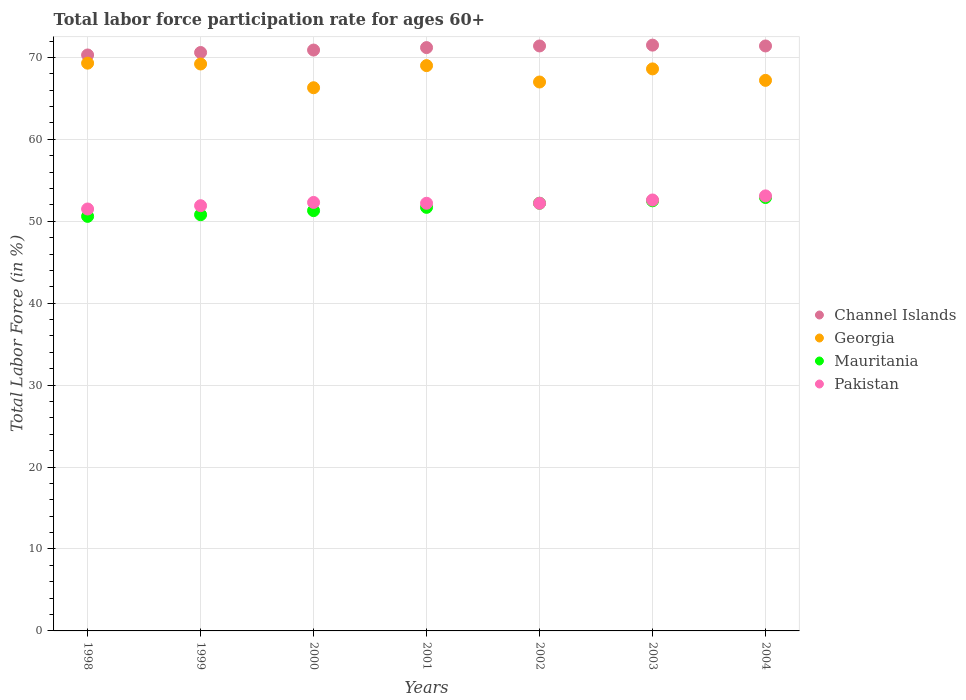What is the labor force participation rate in Pakistan in 2004?
Your response must be concise. 53.1. Across all years, what is the maximum labor force participation rate in Channel Islands?
Provide a succinct answer. 71.5. Across all years, what is the minimum labor force participation rate in Mauritania?
Your response must be concise. 50.6. In which year was the labor force participation rate in Channel Islands minimum?
Give a very brief answer. 1998. What is the total labor force participation rate in Georgia in the graph?
Offer a terse response. 476.6. What is the difference between the labor force participation rate in Georgia in 2002 and the labor force participation rate in Channel Islands in 2000?
Make the answer very short. -3.9. What is the average labor force participation rate in Channel Islands per year?
Provide a short and direct response. 71.04. In the year 1998, what is the difference between the labor force participation rate in Georgia and labor force participation rate in Pakistan?
Your answer should be very brief. 17.8. In how many years, is the labor force participation rate in Pakistan greater than 70 %?
Make the answer very short. 0. What is the ratio of the labor force participation rate in Georgia in 1998 to that in 2003?
Your answer should be very brief. 1.01. Is the difference between the labor force participation rate in Georgia in 1998 and 2001 greater than the difference between the labor force participation rate in Pakistan in 1998 and 2001?
Offer a terse response. Yes. What is the difference between the highest and the second highest labor force participation rate in Channel Islands?
Provide a short and direct response. 0.1. What is the difference between the highest and the lowest labor force participation rate in Mauritania?
Offer a terse response. 2.3. In how many years, is the labor force participation rate in Georgia greater than the average labor force participation rate in Georgia taken over all years?
Offer a terse response. 4. Is it the case that in every year, the sum of the labor force participation rate in Georgia and labor force participation rate in Pakistan  is greater than the sum of labor force participation rate in Mauritania and labor force participation rate in Channel Islands?
Your answer should be very brief. Yes. Is it the case that in every year, the sum of the labor force participation rate in Mauritania and labor force participation rate in Channel Islands  is greater than the labor force participation rate in Georgia?
Your answer should be compact. Yes. Does the labor force participation rate in Channel Islands monotonically increase over the years?
Your answer should be compact. No. How many dotlines are there?
Offer a terse response. 4. How many years are there in the graph?
Keep it short and to the point. 7. Are the values on the major ticks of Y-axis written in scientific E-notation?
Your response must be concise. No. Does the graph contain grids?
Ensure brevity in your answer.  Yes. Where does the legend appear in the graph?
Provide a short and direct response. Center right. How many legend labels are there?
Keep it short and to the point. 4. What is the title of the graph?
Your answer should be compact. Total labor force participation rate for ages 60+. Does "Cote d'Ivoire" appear as one of the legend labels in the graph?
Your answer should be compact. No. What is the label or title of the Y-axis?
Give a very brief answer. Total Labor Force (in %). What is the Total Labor Force (in %) of Channel Islands in 1998?
Offer a very short reply. 70.3. What is the Total Labor Force (in %) of Georgia in 1998?
Keep it short and to the point. 69.3. What is the Total Labor Force (in %) of Mauritania in 1998?
Make the answer very short. 50.6. What is the Total Labor Force (in %) in Pakistan in 1998?
Make the answer very short. 51.5. What is the Total Labor Force (in %) of Channel Islands in 1999?
Keep it short and to the point. 70.6. What is the Total Labor Force (in %) of Georgia in 1999?
Give a very brief answer. 69.2. What is the Total Labor Force (in %) in Mauritania in 1999?
Provide a short and direct response. 50.8. What is the Total Labor Force (in %) in Pakistan in 1999?
Keep it short and to the point. 51.9. What is the Total Labor Force (in %) of Channel Islands in 2000?
Provide a succinct answer. 70.9. What is the Total Labor Force (in %) of Georgia in 2000?
Offer a terse response. 66.3. What is the Total Labor Force (in %) of Mauritania in 2000?
Provide a succinct answer. 51.3. What is the Total Labor Force (in %) of Pakistan in 2000?
Keep it short and to the point. 52.3. What is the Total Labor Force (in %) of Channel Islands in 2001?
Make the answer very short. 71.2. What is the Total Labor Force (in %) of Georgia in 2001?
Offer a terse response. 69. What is the Total Labor Force (in %) of Mauritania in 2001?
Your answer should be compact. 51.7. What is the Total Labor Force (in %) of Pakistan in 2001?
Keep it short and to the point. 52.2. What is the Total Labor Force (in %) in Channel Islands in 2002?
Your answer should be compact. 71.4. What is the Total Labor Force (in %) of Mauritania in 2002?
Keep it short and to the point. 52.2. What is the Total Labor Force (in %) of Pakistan in 2002?
Offer a terse response. 52.2. What is the Total Labor Force (in %) of Channel Islands in 2003?
Provide a succinct answer. 71.5. What is the Total Labor Force (in %) in Georgia in 2003?
Give a very brief answer. 68.6. What is the Total Labor Force (in %) of Mauritania in 2003?
Give a very brief answer. 52.5. What is the Total Labor Force (in %) in Pakistan in 2003?
Ensure brevity in your answer.  52.6. What is the Total Labor Force (in %) of Channel Islands in 2004?
Your answer should be very brief. 71.4. What is the Total Labor Force (in %) of Georgia in 2004?
Offer a terse response. 67.2. What is the Total Labor Force (in %) in Mauritania in 2004?
Provide a succinct answer. 52.9. What is the Total Labor Force (in %) of Pakistan in 2004?
Offer a very short reply. 53.1. Across all years, what is the maximum Total Labor Force (in %) in Channel Islands?
Your answer should be compact. 71.5. Across all years, what is the maximum Total Labor Force (in %) in Georgia?
Make the answer very short. 69.3. Across all years, what is the maximum Total Labor Force (in %) in Mauritania?
Your answer should be compact. 52.9. Across all years, what is the maximum Total Labor Force (in %) of Pakistan?
Keep it short and to the point. 53.1. Across all years, what is the minimum Total Labor Force (in %) of Channel Islands?
Give a very brief answer. 70.3. Across all years, what is the minimum Total Labor Force (in %) of Georgia?
Ensure brevity in your answer.  66.3. Across all years, what is the minimum Total Labor Force (in %) of Mauritania?
Offer a very short reply. 50.6. Across all years, what is the minimum Total Labor Force (in %) of Pakistan?
Make the answer very short. 51.5. What is the total Total Labor Force (in %) in Channel Islands in the graph?
Offer a very short reply. 497.3. What is the total Total Labor Force (in %) in Georgia in the graph?
Provide a short and direct response. 476.6. What is the total Total Labor Force (in %) of Mauritania in the graph?
Your answer should be compact. 362. What is the total Total Labor Force (in %) in Pakistan in the graph?
Offer a terse response. 365.8. What is the difference between the Total Labor Force (in %) of Mauritania in 1998 and that in 1999?
Provide a short and direct response. -0.2. What is the difference between the Total Labor Force (in %) in Mauritania in 1998 and that in 2000?
Offer a terse response. -0.7. What is the difference between the Total Labor Force (in %) in Georgia in 1998 and that in 2002?
Provide a short and direct response. 2.3. What is the difference between the Total Labor Force (in %) in Mauritania in 1998 and that in 2002?
Provide a short and direct response. -1.6. What is the difference between the Total Labor Force (in %) in Channel Islands in 1998 and that in 2003?
Ensure brevity in your answer.  -1.2. What is the difference between the Total Labor Force (in %) in Pakistan in 1998 and that in 2003?
Make the answer very short. -1.1. What is the difference between the Total Labor Force (in %) of Georgia in 1998 and that in 2004?
Your answer should be very brief. 2.1. What is the difference between the Total Labor Force (in %) in Mauritania in 1998 and that in 2004?
Keep it short and to the point. -2.3. What is the difference between the Total Labor Force (in %) in Pakistan in 1998 and that in 2004?
Your response must be concise. -1.6. What is the difference between the Total Labor Force (in %) in Channel Islands in 1999 and that in 2000?
Provide a short and direct response. -0.3. What is the difference between the Total Labor Force (in %) of Georgia in 1999 and that in 2000?
Ensure brevity in your answer.  2.9. What is the difference between the Total Labor Force (in %) in Mauritania in 1999 and that in 2000?
Make the answer very short. -0.5. What is the difference between the Total Labor Force (in %) of Georgia in 1999 and that in 2001?
Keep it short and to the point. 0.2. What is the difference between the Total Labor Force (in %) in Channel Islands in 1999 and that in 2002?
Make the answer very short. -0.8. What is the difference between the Total Labor Force (in %) of Mauritania in 1999 and that in 2003?
Your response must be concise. -1.7. What is the difference between the Total Labor Force (in %) in Pakistan in 1999 and that in 2003?
Your answer should be very brief. -0.7. What is the difference between the Total Labor Force (in %) of Channel Islands in 1999 and that in 2004?
Make the answer very short. -0.8. What is the difference between the Total Labor Force (in %) in Channel Islands in 2000 and that in 2001?
Offer a very short reply. -0.3. What is the difference between the Total Labor Force (in %) of Georgia in 2000 and that in 2001?
Provide a succinct answer. -2.7. What is the difference between the Total Labor Force (in %) in Pakistan in 2000 and that in 2001?
Make the answer very short. 0.1. What is the difference between the Total Labor Force (in %) in Channel Islands in 2000 and that in 2002?
Make the answer very short. -0.5. What is the difference between the Total Labor Force (in %) in Georgia in 2000 and that in 2002?
Offer a terse response. -0.7. What is the difference between the Total Labor Force (in %) in Pakistan in 2000 and that in 2002?
Keep it short and to the point. 0.1. What is the difference between the Total Labor Force (in %) of Mauritania in 2000 and that in 2003?
Ensure brevity in your answer.  -1.2. What is the difference between the Total Labor Force (in %) of Pakistan in 2000 and that in 2003?
Make the answer very short. -0.3. What is the difference between the Total Labor Force (in %) of Georgia in 2001 and that in 2002?
Provide a short and direct response. 2. What is the difference between the Total Labor Force (in %) of Mauritania in 2001 and that in 2003?
Provide a short and direct response. -0.8. What is the difference between the Total Labor Force (in %) in Pakistan in 2001 and that in 2003?
Your answer should be compact. -0.4. What is the difference between the Total Labor Force (in %) in Channel Islands in 2001 and that in 2004?
Your answer should be very brief. -0.2. What is the difference between the Total Labor Force (in %) in Georgia in 2001 and that in 2004?
Provide a short and direct response. 1.8. What is the difference between the Total Labor Force (in %) in Mauritania in 2001 and that in 2004?
Your answer should be very brief. -1.2. What is the difference between the Total Labor Force (in %) of Pakistan in 2001 and that in 2004?
Ensure brevity in your answer.  -0.9. What is the difference between the Total Labor Force (in %) of Georgia in 2002 and that in 2003?
Ensure brevity in your answer.  -1.6. What is the difference between the Total Labor Force (in %) in Mauritania in 2002 and that in 2003?
Offer a terse response. -0.3. What is the difference between the Total Labor Force (in %) in Georgia in 2002 and that in 2004?
Offer a very short reply. -0.2. What is the difference between the Total Labor Force (in %) in Channel Islands in 2003 and that in 2004?
Your answer should be compact. 0.1. What is the difference between the Total Labor Force (in %) of Georgia in 2003 and that in 2004?
Keep it short and to the point. 1.4. What is the difference between the Total Labor Force (in %) in Mauritania in 2003 and that in 2004?
Your answer should be compact. -0.4. What is the difference between the Total Labor Force (in %) of Channel Islands in 1998 and the Total Labor Force (in %) of Georgia in 1999?
Offer a very short reply. 1.1. What is the difference between the Total Labor Force (in %) of Channel Islands in 1998 and the Total Labor Force (in %) of Mauritania in 1999?
Make the answer very short. 19.5. What is the difference between the Total Labor Force (in %) of Mauritania in 1998 and the Total Labor Force (in %) of Pakistan in 1999?
Your answer should be very brief. -1.3. What is the difference between the Total Labor Force (in %) in Channel Islands in 1998 and the Total Labor Force (in %) in Mauritania in 2000?
Offer a very short reply. 19. What is the difference between the Total Labor Force (in %) in Channel Islands in 1998 and the Total Labor Force (in %) in Pakistan in 2000?
Keep it short and to the point. 18. What is the difference between the Total Labor Force (in %) of Georgia in 1998 and the Total Labor Force (in %) of Mauritania in 2000?
Offer a very short reply. 18. What is the difference between the Total Labor Force (in %) of Channel Islands in 1998 and the Total Labor Force (in %) of Mauritania in 2001?
Your answer should be very brief. 18.6. What is the difference between the Total Labor Force (in %) in Georgia in 1998 and the Total Labor Force (in %) in Mauritania in 2001?
Your answer should be compact. 17.6. What is the difference between the Total Labor Force (in %) in Channel Islands in 1998 and the Total Labor Force (in %) in Pakistan in 2002?
Keep it short and to the point. 18.1. What is the difference between the Total Labor Force (in %) in Channel Islands in 1998 and the Total Labor Force (in %) in Mauritania in 2003?
Make the answer very short. 17.8. What is the difference between the Total Labor Force (in %) of Channel Islands in 1998 and the Total Labor Force (in %) of Pakistan in 2003?
Give a very brief answer. 17.7. What is the difference between the Total Labor Force (in %) in Georgia in 1998 and the Total Labor Force (in %) in Pakistan in 2003?
Your answer should be compact. 16.7. What is the difference between the Total Labor Force (in %) in Channel Islands in 1998 and the Total Labor Force (in %) in Georgia in 2004?
Ensure brevity in your answer.  3.1. What is the difference between the Total Labor Force (in %) of Channel Islands in 1998 and the Total Labor Force (in %) of Pakistan in 2004?
Your response must be concise. 17.2. What is the difference between the Total Labor Force (in %) of Georgia in 1998 and the Total Labor Force (in %) of Mauritania in 2004?
Make the answer very short. 16.4. What is the difference between the Total Labor Force (in %) of Channel Islands in 1999 and the Total Labor Force (in %) of Mauritania in 2000?
Make the answer very short. 19.3. What is the difference between the Total Labor Force (in %) of Channel Islands in 1999 and the Total Labor Force (in %) of Pakistan in 2000?
Give a very brief answer. 18.3. What is the difference between the Total Labor Force (in %) of Channel Islands in 1999 and the Total Labor Force (in %) of Georgia in 2001?
Offer a terse response. 1.6. What is the difference between the Total Labor Force (in %) in Georgia in 1999 and the Total Labor Force (in %) in Mauritania in 2001?
Ensure brevity in your answer.  17.5. What is the difference between the Total Labor Force (in %) of Mauritania in 1999 and the Total Labor Force (in %) of Pakistan in 2001?
Make the answer very short. -1.4. What is the difference between the Total Labor Force (in %) in Channel Islands in 1999 and the Total Labor Force (in %) in Georgia in 2002?
Offer a very short reply. 3.6. What is the difference between the Total Labor Force (in %) of Channel Islands in 1999 and the Total Labor Force (in %) of Pakistan in 2002?
Keep it short and to the point. 18.4. What is the difference between the Total Labor Force (in %) of Georgia in 1999 and the Total Labor Force (in %) of Pakistan in 2002?
Make the answer very short. 17. What is the difference between the Total Labor Force (in %) in Channel Islands in 1999 and the Total Labor Force (in %) in Mauritania in 2003?
Offer a very short reply. 18.1. What is the difference between the Total Labor Force (in %) in Channel Islands in 1999 and the Total Labor Force (in %) in Pakistan in 2003?
Offer a terse response. 18. What is the difference between the Total Labor Force (in %) of Georgia in 1999 and the Total Labor Force (in %) of Pakistan in 2003?
Ensure brevity in your answer.  16.6. What is the difference between the Total Labor Force (in %) in Channel Islands in 1999 and the Total Labor Force (in %) in Georgia in 2004?
Make the answer very short. 3.4. What is the difference between the Total Labor Force (in %) of Channel Islands in 1999 and the Total Labor Force (in %) of Mauritania in 2004?
Provide a succinct answer. 17.7. What is the difference between the Total Labor Force (in %) in Georgia in 1999 and the Total Labor Force (in %) in Mauritania in 2004?
Give a very brief answer. 16.3. What is the difference between the Total Labor Force (in %) of Channel Islands in 2000 and the Total Labor Force (in %) of Georgia in 2001?
Keep it short and to the point. 1.9. What is the difference between the Total Labor Force (in %) of Channel Islands in 2000 and the Total Labor Force (in %) of Mauritania in 2001?
Offer a very short reply. 19.2. What is the difference between the Total Labor Force (in %) in Georgia in 2000 and the Total Labor Force (in %) in Pakistan in 2001?
Keep it short and to the point. 14.1. What is the difference between the Total Labor Force (in %) of Mauritania in 2000 and the Total Labor Force (in %) of Pakistan in 2001?
Offer a very short reply. -0.9. What is the difference between the Total Labor Force (in %) in Channel Islands in 2000 and the Total Labor Force (in %) in Pakistan in 2002?
Your response must be concise. 18.7. What is the difference between the Total Labor Force (in %) in Georgia in 2000 and the Total Labor Force (in %) in Mauritania in 2002?
Keep it short and to the point. 14.1. What is the difference between the Total Labor Force (in %) in Georgia in 2000 and the Total Labor Force (in %) in Pakistan in 2002?
Your answer should be compact. 14.1. What is the difference between the Total Labor Force (in %) in Channel Islands in 2000 and the Total Labor Force (in %) in Mauritania in 2003?
Your answer should be compact. 18.4. What is the difference between the Total Labor Force (in %) in Channel Islands in 2000 and the Total Labor Force (in %) in Pakistan in 2003?
Your response must be concise. 18.3. What is the difference between the Total Labor Force (in %) of Georgia in 2000 and the Total Labor Force (in %) of Mauritania in 2003?
Your answer should be compact. 13.8. What is the difference between the Total Labor Force (in %) in Mauritania in 2000 and the Total Labor Force (in %) in Pakistan in 2003?
Keep it short and to the point. -1.3. What is the difference between the Total Labor Force (in %) in Channel Islands in 2000 and the Total Labor Force (in %) in Georgia in 2004?
Your answer should be very brief. 3.7. What is the difference between the Total Labor Force (in %) in Channel Islands in 2000 and the Total Labor Force (in %) in Pakistan in 2004?
Make the answer very short. 17.8. What is the difference between the Total Labor Force (in %) of Georgia in 2000 and the Total Labor Force (in %) of Pakistan in 2004?
Provide a succinct answer. 13.2. What is the difference between the Total Labor Force (in %) in Mauritania in 2000 and the Total Labor Force (in %) in Pakistan in 2004?
Give a very brief answer. -1.8. What is the difference between the Total Labor Force (in %) of Channel Islands in 2001 and the Total Labor Force (in %) of Georgia in 2002?
Your response must be concise. 4.2. What is the difference between the Total Labor Force (in %) in Channel Islands in 2001 and the Total Labor Force (in %) in Mauritania in 2002?
Provide a short and direct response. 19. What is the difference between the Total Labor Force (in %) in Channel Islands in 2001 and the Total Labor Force (in %) in Pakistan in 2002?
Provide a succinct answer. 19. What is the difference between the Total Labor Force (in %) of Mauritania in 2001 and the Total Labor Force (in %) of Pakistan in 2002?
Offer a very short reply. -0.5. What is the difference between the Total Labor Force (in %) in Georgia in 2001 and the Total Labor Force (in %) in Pakistan in 2003?
Your response must be concise. 16.4. What is the difference between the Total Labor Force (in %) of Mauritania in 2001 and the Total Labor Force (in %) of Pakistan in 2003?
Provide a succinct answer. -0.9. What is the difference between the Total Labor Force (in %) of Channel Islands in 2001 and the Total Labor Force (in %) of Mauritania in 2004?
Ensure brevity in your answer.  18.3. What is the difference between the Total Labor Force (in %) in Channel Islands in 2001 and the Total Labor Force (in %) in Pakistan in 2004?
Make the answer very short. 18.1. What is the difference between the Total Labor Force (in %) of Georgia in 2001 and the Total Labor Force (in %) of Mauritania in 2004?
Offer a terse response. 16.1. What is the difference between the Total Labor Force (in %) of Georgia in 2001 and the Total Labor Force (in %) of Pakistan in 2004?
Your answer should be compact. 15.9. What is the difference between the Total Labor Force (in %) of Mauritania in 2001 and the Total Labor Force (in %) of Pakistan in 2004?
Keep it short and to the point. -1.4. What is the difference between the Total Labor Force (in %) in Channel Islands in 2002 and the Total Labor Force (in %) in Mauritania in 2003?
Give a very brief answer. 18.9. What is the difference between the Total Labor Force (in %) in Channel Islands in 2002 and the Total Labor Force (in %) in Pakistan in 2003?
Your answer should be very brief. 18.8. What is the difference between the Total Labor Force (in %) in Mauritania in 2002 and the Total Labor Force (in %) in Pakistan in 2003?
Your response must be concise. -0.4. What is the difference between the Total Labor Force (in %) of Channel Islands in 2002 and the Total Labor Force (in %) of Georgia in 2004?
Ensure brevity in your answer.  4.2. What is the difference between the Total Labor Force (in %) in Channel Islands in 2002 and the Total Labor Force (in %) in Pakistan in 2004?
Offer a terse response. 18.3. What is the difference between the Total Labor Force (in %) of Georgia in 2002 and the Total Labor Force (in %) of Pakistan in 2004?
Offer a terse response. 13.9. What is the difference between the Total Labor Force (in %) in Mauritania in 2002 and the Total Labor Force (in %) in Pakistan in 2004?
Offer a very short reply. -0.9. What is the difference between the Total Labor Force (in %) of Channel Islands in 2003 and the Total Labor Force (in %) of Pakistan in 2004?
Give a very brief answer. 18.4. What is the difference between the Total Labor Force (in %) of Mauritania in 2003 and the Total Labor Force (in %) of Pakistan in 2004?
Your response must be concise. -0.6. What is the average Total Labor Force (in %) in Channel Islands per year?
Your response must be concise. 71.04. What is the average Total Labor Force (in %) in Georgia per year?
Ensure brevity in your answer.  68.09. What is the average Total Labor Force (in %) in Mauritania per year?
Your response must be concise. 51.71. What is the average Total Labor Force (in %) in Pakistan per year?
Give a very brief answer. 52.26. In the year 1998, what is the difference between the Total Labor Force (in %) of Channel Islands and Total Labor Force (in %) of Pakistan?
Make the answer very short. 18.8. In the year 1998, what is the difference between the Total Labor Force (in %) of Mauritania and Total Labor Force (in %) of Pakistan?
Offer a very short reply. -0.9. In the year 1999, what is the difference between the Total Labor Force (in %) of Channel Islands and Total Labor Force (in %) of Georgia?
Give a very brief answer. 1.4. In the year 1999, what is the difference between the Total Labor Force (in %) in Channel Islands and Total Labor Force (in %) in Mauritania?
Provide a short and direct response. 19.8. In the year 1999, what is the difference between the Total Labor Force (in %) of Channel Islands and Total Labor Force (in %) of Pakistan?
Offer a terse response. 18.7. In the year 1999, what is the difference between the Total Labor Force (in %) in Georgia and Total Labor Force (in %) in Pakistan?
Offer a very short reply. 17.3. In the year 2000, what is the difference between the Total Labor Force (in %) in Channel Islands and Total Labor Force (in %) in Mauritania?
Provide a succinct answer. 19.6. In the year 2000, what is the difference between the Total Labor Force (in %) of Channel Islands and Total Labor Force (in %) of Pakistan?
Offer a terse response. 18.6. In the year 2000, what is the difference between the Total Labor Force (in %) of Mauritania and Total Labor Force (in %) of Pakistan?
Provide a short and direct response. -1. In the year 2001, what is the difference between the Total Labor Force (in %) of Channel Islands and Total Labor Force (in %) of Mauritania?
Your answer should be very brief. 19.5. In the year 2001, what is the difference between the Total Labor Force (in %) in Channel Islands and Total Labor Force (in %) in Pakistan?
Your response must be concise. 19. In the year 2001, what is the difference between the Total Labor Force (in %) of Georgia and Total Labor Force (in %) of Pakistan?
Make the answer very short. 16.8. In the year 2001, what is the difference between the Total Labor Force (in %) in Mauritania and Total Labor Force (in %) in Pakistan?
Offer a very short reply. -0.5. In the year 2002, what is the difference between the Total Labor Force (in %) of Channel Islands and Total Labor Force (in %) of Mauritania?
Keep it short and to the point. 19.2. In the year 2002, what is the difference between the Total Labor Force (in %) of Georgia and Total Labor Force (in %) of Mauritania?
Provide a short and direct response. 14.8. In the year 2003, what is the difference between the Total Labor Force (in %) in Channel Islands and Total Labor Force (in %) in Georgia?
Your answer should be very brief. 2.9. In the year 2003, what is the difference between the Total Labor Force (in %) in Channel Islands and Total Labor Force (in %) in Mauritania?
Your response must be concise. 19. In the year 2004, what is the difference between the Total Labor Force (in %) of Channel Islands and Total Labor Force (in %) of Mauritania?
Provide a succinct answer. 18.5. In the year 2004, what is the difference between the Total Labor Force (in %) of Channel Islands and Total Labor Force (in %) of Pakistan?
Make the answer very short. 18.3. In the year 2004, what is the difference between the Total Labor Force (in %) in Georgia and Total Labor Force (in %) in Mauritania?
Ensure brevity in your answer.  14.3. What is the ratio of the Total Labor Force (in %) in Channel Islands in 1998 to that in 1999?
Provide a short and direct response. 1. What is the ratio of the Total Labor Force (in %) of Mauritania in 1998 to that in 1999?
Your answer should be very brief. 1. What is the ratio of the Total Labor Force (in %) of Channel Islands in 1998 to that in 2000?
Ensure brevity in your answer.  0.99. What is the ratio of the Total Labor Force (in %) of Georgia in 1998 to that in 2000?
Provide a short and direct response. 1.05. What is the ratio of the Total Labor Force (in %) in Mauritania in 1998 to that in 2000?
Keep it short and to the point. 0.99. What is the ratio of the Total Labor Force (in %) in Pakistan in 1998 to that in 2000?
Your response must be concise. 0.98. What is the ratio of the Total Labor Force (in %) of Channel Islands in 1998 to that in 2001?
Keep it short and to the point. 0.99. What is the ratio of the Total Labor Force (in %) in Mauritania in 1998 to that in 2001?
Offer a terse response. 0.98. What is the ratio of the Total Labor Force (in %) in Pakistan in 1998 to that in 2001?
Your answer should be very brief. 0.99. What is the ratio of the Total Labor Force (in %) of Channel Islands in 1998 to that in 2002?
Give a very brief answer. 0.98. What is the ratio of the Total Labor Force (in %) of Georgia in 1998 to that in 2002?
Keep it short and to the point. 1.03. What is the ratio of the Total Labor Force (in %) of Mauritania in 1998 to that in 2002?
Make the answer very short. 0.97. What is the ratio of the Total Labor Force (in %) in Pakistan in 1998 to that in 2002?
Ensure brevity in your answer.  0.99. What is the ratio of the Total Labor Force (in %) in Channel Islands in 1998 to that in 2003?
Offer a very short reply. 0.98. What is the ratio of the Total Labor Force (in %) of Georgia in 1998 to that in 2003?
Your response must be concise. 1.01. What is the ratio of the Total Labor Force (in %) in Mauritania in 1998 to that in 2003?
Offer a terse response. 0.96. What is the ratio of the Total Labor Force (in %) in Pakistan in 1998 to that in 2003?
Make the answer very short. 0.98. What is the ratio of the Total Labor Force (in %) of Channel Islands in 1998 to that in 2004?
Keep it short and to the point. 0.98. What is the ratio of the Total Labor Force (in %) of Georgia in 1998 to that in 2004?
Give a very brief answer. 1.03. What is the ratio of the Total Labor Force (in %) of Mauritania in 1998 to that in 2004?
Offer a terse response. 0.96. What is the ratio of the Total Labor Force (in %) in Pakistan in 1998 to that in 2004?
Keep it short and to the point. 0.97. What is the ratio of the Total Labor Force (in %) of Georgia in 1999 to that in 2000?
Make the answer very short. 1.04. What is the ratio of the Total Labor Force (in %) of Mauritania in 1999 to that in 2000?
Your answer should be very brief. 0.99. What is the ratio of the Total Labor Force (in %) in Pakistan in 1999 to that in 2000?
Provide a short and direct response. 0.99. What is the ratio of the Total Labor Force (in %) in Mauritania in 1999 to that in 2001?
Offer a very short reply. 0.98. What is the ratio of the Total Labor Force (in %) of Georgia in 1999 to that in 2002?
Your answer should be compact. 1.03. What is the ratio of the Total Labor Force (in %) of Mauritania in 1999 to that in 2002?
Make the answer very short. 0.97. What is the ratio of the Total Labor Force (in %) in Pakistan in 1999 to that in 2002?
Ensure brevity in your answer.  0.99. What is the ratio of the Total Labor Force (in %) of Channel Islands in 1999 to that in 2003?
Your answer should be compact. 0.99. What is the ratio of the Total Labor Force (in %) in Georgia in 1999 to that in 2003?
Give a very brief answer. 1.01. What is the ratio of the Total Labor Force (in %) of Mauritania in 1999 to that in 2003?
Provide a short and direct response. 0.97. What is the ratio of the Total Labor Force (in %) of Pakistan in 1999 to that in 2003?
Offer a very short reply. 0.99. What is the ratio of the Total Labor Force (in %) of Channel Islands in 1999 to that in 2004?
Your response must be concise. 0.99. What is the ratio of the Total Labor Force (in %) of Georgia in 1999 to that in 2004?
Give a very brief answer. 1.03. What is the ratio of the Total Labor Force (in %) of Mauritania in 1999 to that in 2004?
Keep it short and to the point. 0.96. What is the ratio of the Total Labor Force (in %) in Pakistan in 1999 to that in 2004?
Ensure brevity in your answer.  0.98. What is the ratio of the Total Labor Force (in %) of Georgia in 2000 to that in 2001?
Make the answer very short. 0.96. What is the ratio of the Total Labor Force (in %) of Mauritania in 2000 to that in 2001?
Your response must be concise. 0.99. What is the ratio of the Total Labor Force (in %) in Pakistan in 2000 to that in 2001?
Your answer should be very brief. 1. What is the ratio of the Total Labor Force (in %) of Georgia in 2000 to that in 2002?
Provide a succinct answer. 0.99. What is the ratio of the Total Labor Force (in %) of Mauritania in 2000 to that in 2002?
Offer a terse response. 0.98. What is the ratio of the Total Labor Force (in %) of Georgia in 2000 to that in 2003?
Your response must be concise. 0.97. What is the ratio of the Total Labor Force (in %) of Mauritania in 2000 to that in 2003?
Your answer should be very brief. 0.98. What is the ratio of the Total Labor Force (in %) of Georgia in 2000 to that in 2004?
Provide a short and direct response. 0.99. What is the ratio of the Total Labor Force (in %) in Mauritania in 2000 to that in 2004?
Give a very brief answer. 0.97. What is the ratio of the Total Labor Force (in %) of Pakistan in 2000 to that in 2004?
Your answer should be compact. 0.98. What is the ratio of the Total Labor Force (in %) of Georgia in 2001 to that in 2002?
Give a very brief answer. 1.03. What is the ratio of the Total Labor Force (in %) in Pakistan in 2001 to that in 2002?
Your answer should be compact. 1. What is the ratio of the Total Labor Force (in %) of Channel Islands in 2001 to that in 2003?
Ensure brevity in your answer.  1. What is the ratio of the Total Labor Force (in %) in Mauritania in 2001 to that in 2003?
Make the answer very short. 0.98. What is the ratio of the Total Labor Force (in %) of Georgia in 2001 to that in 2004?
Ensure brevity in your answer.  1.03. What is the ratio of the Total Labor Force (in %) of Mauritania in 2001 to that in 2004?
Offer a terse response. 0.98. What is the ratio of the Total Labor Force (in %) in Pakistan in 2001 to that in 2004?
Give a very brief answer. 0.98. What is the ratio of the Total Labor Force (in %) in Georgia in 2002 to that in 2003?
Offer a very short reply. 0.98. What is the ratio of the Total Labor Force (in %) in Channel Islands in 2002 to that in 2004?
Ensure brevity in your answer.  1. What is the ratio of the Total Labor Force (in %) in Pakistan in 2002 to that in 2004?
Keep it short and to the point. 0.98. What is the ratio of the Total Labor Force (in %) of Channel Islands in 2003 to that in 2004?
Provide a short and direct response. 1. What is the ratio of the Total Labor Force (in %) in Georgia in 2003 to that in 2004?
Provide a short and direct response. 1.02. What is the ratio of the Total Labor Force (in %) in Pakistan in 2003 to that in 2004?
Your answer should be compact. 0.99. What is the difference between the highest and the second highest Total Labor Force (in %) of Georgia?
Offer a very short reply. 0.1. What is the difference between the highest and the second highest Total Labor Force (in %) of Mauritania?
Your response must be concise. 0.4. What is the difference between the highest and the second highest Total Labor Force (in %) in Pakistan?
Ensure brevity in your answer.  0.5. What is the difference between the highest and the lowest Total Labor Force (in %) of Georgia?
Make the answer very short. 3. What is the difference between the highest and the lowest Total Labor Force (in %) of Mauritania?
Provide a short and direct response. 2.3. 